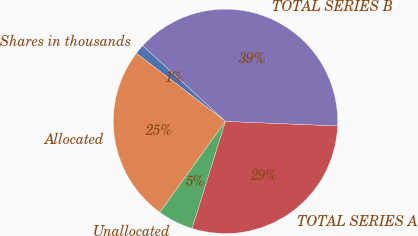<chart> <loc_0><loc_0><loc_500><loc_500><pie_chart><fcel>Shares in thousands<fcel>Allocated<fcel>Unallocated<fcel>TOTAL SERIES A<fcel>TOTAL SERIES B<nl><fcel>1.41%<fcel>25.42%<fcel>5.15%<fcel>29.16%<fcel>38.86%<nl></chart> 